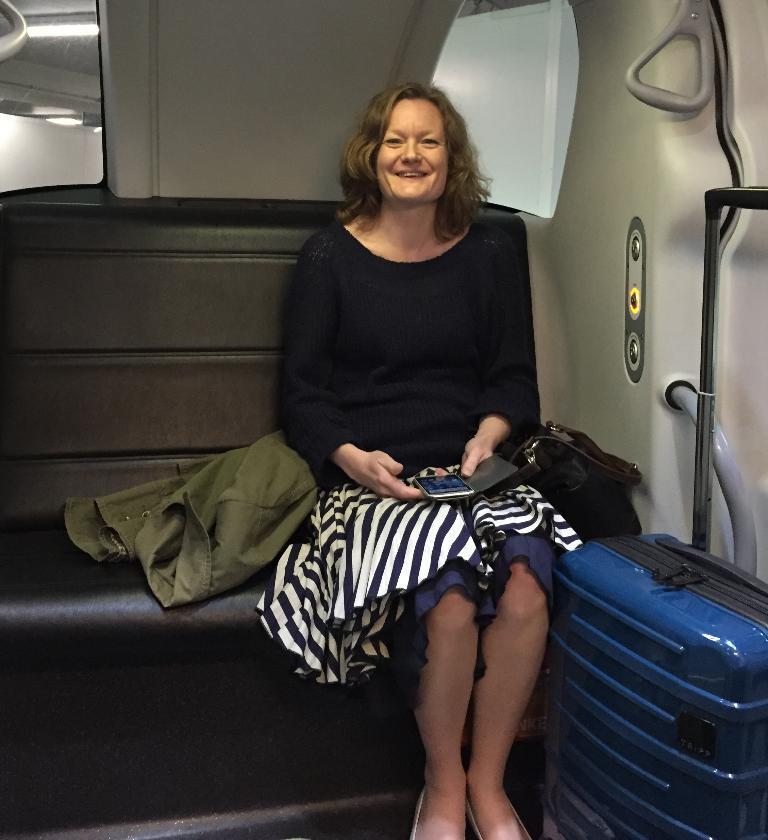Could you give a brief overview of what you see in this image? In this picture there is a lady who is sitting at the right side of the image with luggage and a hand bag, there is a jacket at the right side of the lady, it seems to be she is sitting in a train. 